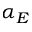<formula> <loc_0><loc_0><loc_500><loc_500>\alpha _ { E }</formula> 